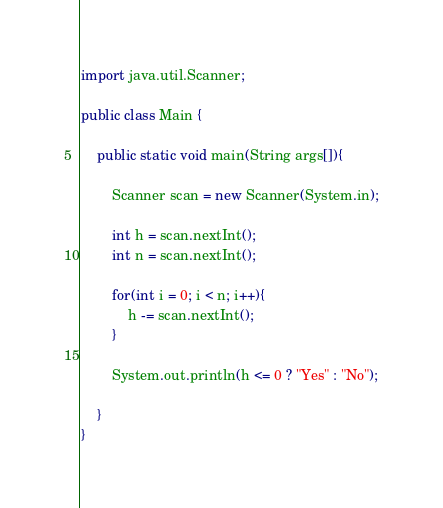<code> <loc_0><loc_0><loc_500><loc_500><_Java_>import java.util.Scanner;

public class Main {

	public static void main(String args[]){

		Scanner scan = new Scanner(System.in);

		int h = scan.nextInt();
		int n = scan.nextInt();
		
		for(int i = 0; i < n; i++){
			h -= scan.nextInt(); 
		}
		
		System.out.println(h <= 0 ? "Yes" : "No");
		
	}
}</code> 